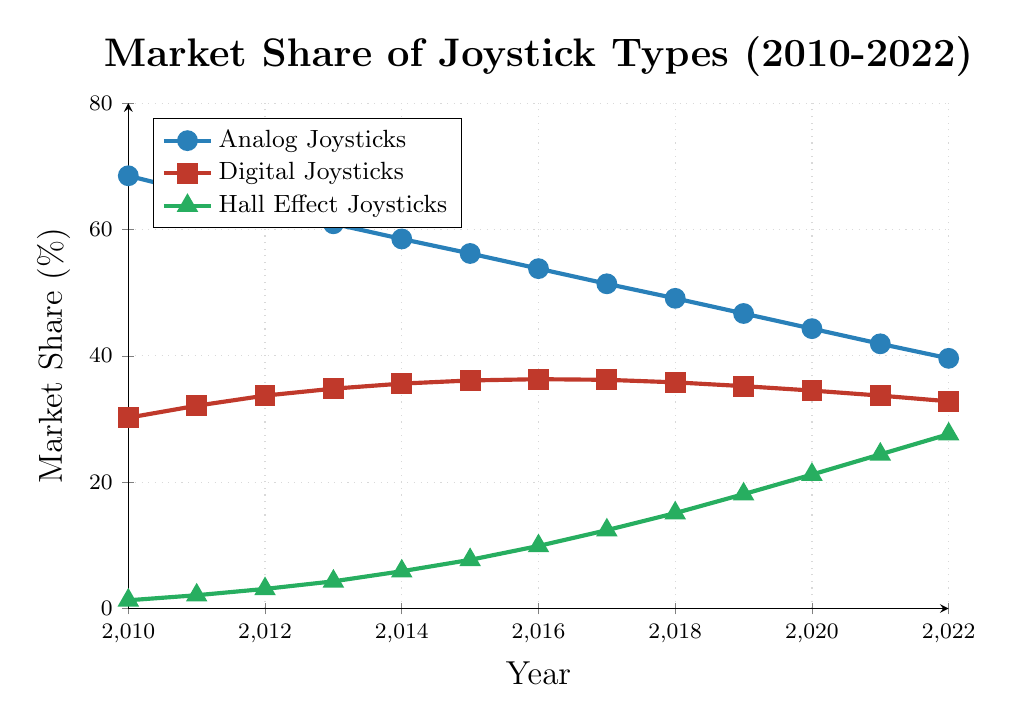What is the market share of Analog Joysticks in 2022? The market share can be read directly from the figure by locating the data point corresponding to Analog Joysticks in the year 2022.
Answer: 39.6% Which joystick type had the highest market share in 2015? By comparing the vertical position of the three lines at the year 2015, the Analog Joysticks line is the highest.
Answer: Analog Joysticks Did the market share of Digital Joysticks increase or decrease between 2010 and 2022? By comparing the value at 2010 (30.2%) and 2022 (32.8%), we can see that the market share increased.
Answer: Increase In what year did Analog Joysticks fall below 50% market share for the first time? By examining the Analog Joysticks line, it falls below the 50% mark for the first time in 2018.
Answer: 2018 What is the difference in market share between Analog and Digital Joysticks in 2017? The market share of Analog Joysticks in 2017 is 51.4% and for Digital Joysticks is 36.2%. The difference is 51.4% - 36.2%.
Answer: 15.2% Which joystick type had the most considerable growth in market share over the period 2010-2022? By examining the increase in market share for each joystick type, Hall Effect Joysticks increased the most (from 1.3% to 27.6%).
Answer: Hall Effect Joysticks What is the average market share of Digital Joysticks over the years presented? Sum all the market share values for Digital Joysticks and divide by the number of years (13). (30.2 + 32.1 + 33.7 + 34.8 + 35.6 + 36.1 + 36.3 + 36.2 + 35.8 + 35.2 + 34.5 + 33.7 + 32.8) / 13.
Answer: 34.5% What is the trend of the Hall Effect Joystick market share over the years? By observing the slope of the Hall Effect Joystick line over time, we see that it consistently increases each year.
Answer: Increasing 